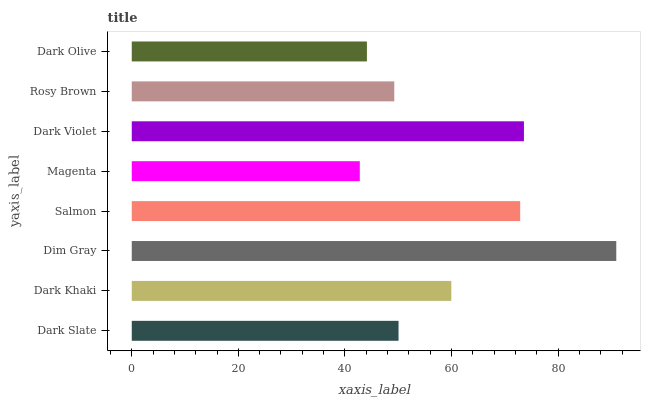Is Magenta the minimum?
Answer yes or no. Yes. Is Dim Gray the maximum?
Answer yes or no. Yes. Is Dark Khaki the minimum?
Answer yes or no. No. Is Dark Khaki the maximum?
Answer yes or no. No. Is Dark Khaki greater than Dark Slate?
Answer yes or no. Yes. Is Dark Slate less than Dark Khaki?
Answer yes or no. Yes. Is Dark Slate greater than Dark Khaki?
Answer yes or no. No. Is Dark Khaki less than Dark Slate?
Answer yes or no. No. Is Dark Khaki the high median?
Answer yes or no. Yes. Is Dark Slate the low median?
Answer yes or no. Yes. Is Dim Gray the high median?
Answer yes or no. No. Is Magenta the low median?
Answer yes or no. No. 